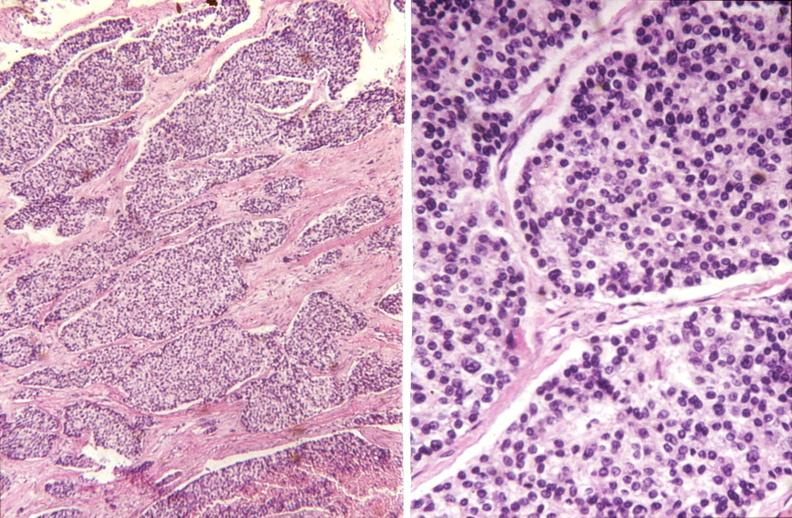where is this part in the figure?
Answer the question using a single word or phrase. Endocrine system 